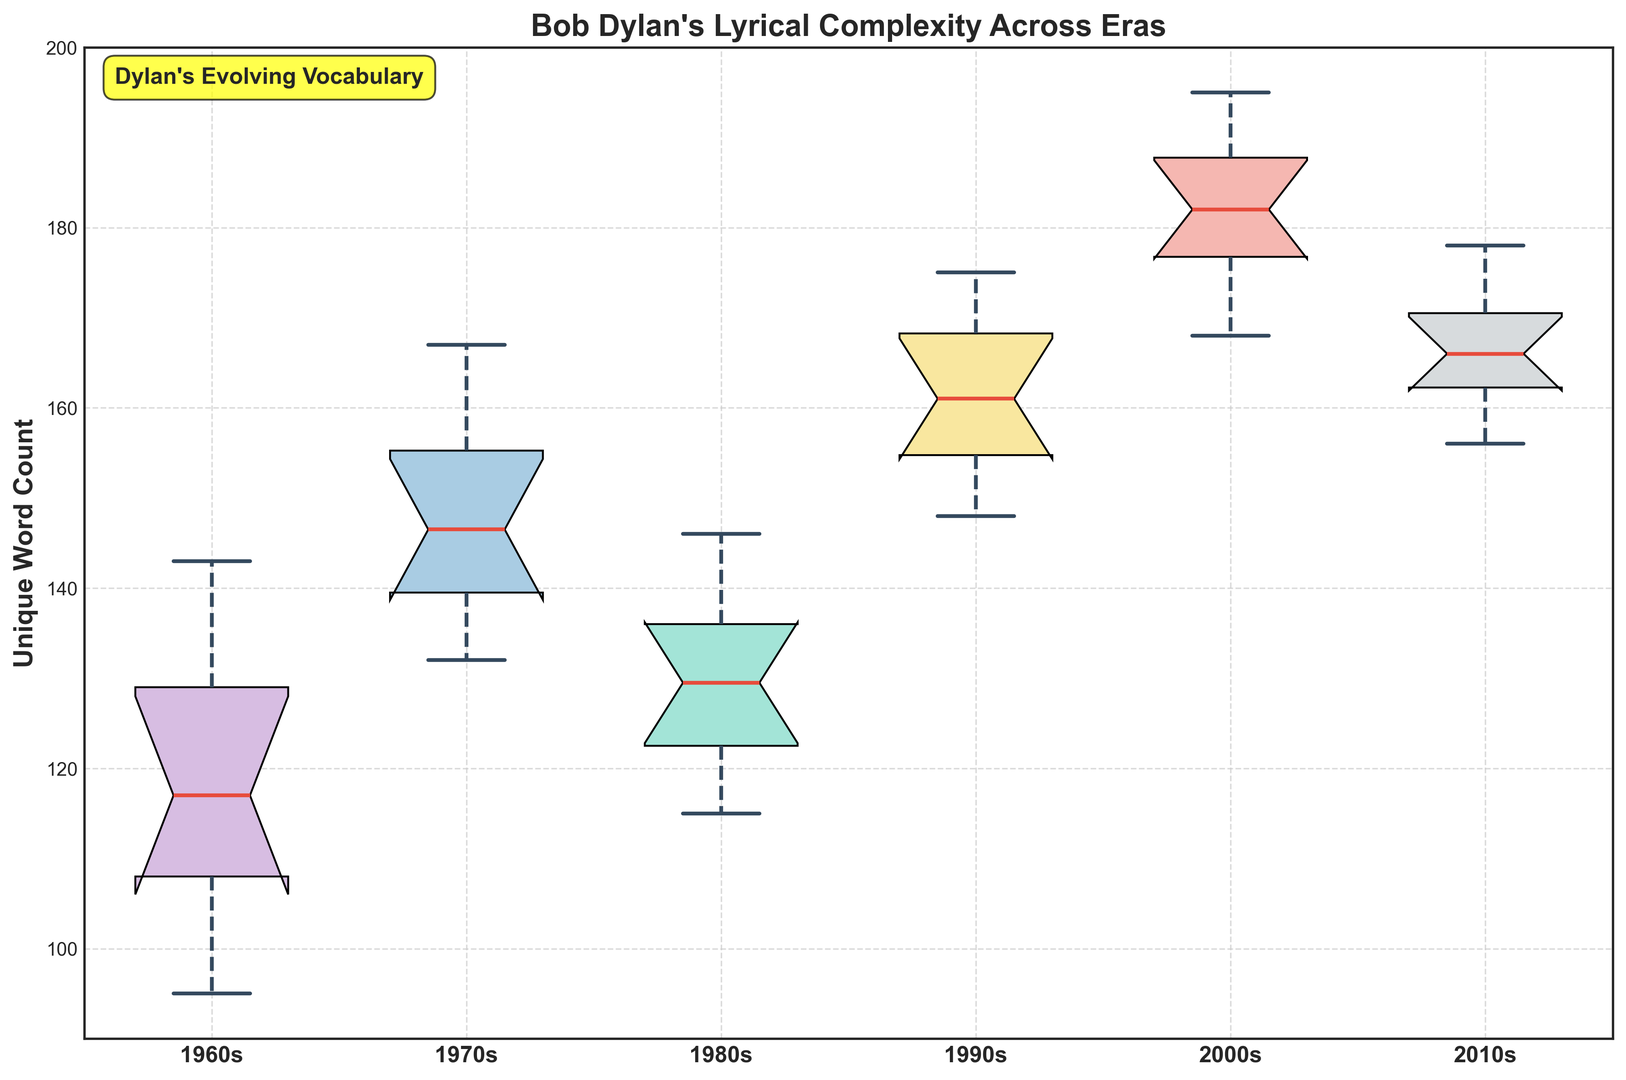Which era has the highest median unique word count? To identify the era with the highest median unique word count, compare the central line (median) of the boxes for all eras. The era with the highest central line value is the 2000s.
Answer: 2000s Which era shows the greatest variation in unique word count? Variation is indicated by the height difference between the top and bottom whiskers of a box plot. The 2000s era has the largest range between its whiskers, indicating the greatest variation.
Answer: 2000s What is the approximate interquartile range (IQR) for the 1990s? The IQR is the difference between the top (75th percentile) and bottom (25th percentile) edges of the box. For the 1990s, estimate the edges: about 169 (75th percentile) and 153 (25th percentile). IQR = 169 - 153 = 16.
Answer: 16 Compare the median unique word counts of the 1960s and the 2010s. Which era has a higher median? The median is represented by the central line in the box plot. Compare the 1960s and 2010s median lines. The 2010s median is higher.
Answer: 2010s Which era shows the smallest variation in unique word count? Variation is indicated by the height difference between the top and bottom whiskers. The 2010s have the smallest range between their whiskers, indicating the smallest variation.
Answer: 2010s What is the median unique word count for the 1980s? The median is represented by the central line in the 1980s box. It is approximately 130.
Answer: 130 Which era has the highest upper quartile value? The upper quartile is represented by the top edge of each box. The 2000s era has the highest top edge value.
Answer: 2000s How do the whiskers of the 1970s compare to those of the 1980s? The whiskers show the range of the data excluding outliers. The 1970s whiskers are longer, indicating a larger range of unique word counts compared to the 1980s.
Answer: Longer In terms of lyrical complexity, which eras show a clear increasing trend in median unique word count over time? Examine the median values of each era from the 1960s to the 2010s. There is an increasing trend in median unique word count from the 1960s through the 2000s.
Answer: 1960s to 2000s Which era has the most outliers, and how are these visually indicated? Outliers are shown as individual points outside the whiskers. The 2000s have the most visible outliers above the upper whiskers.
Answer: 2000s 